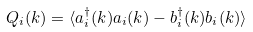<formula> <loc_0><loc_0><loc_500><loc_500>Q _ { i } ( k ) = \langle a _ { i } ^ { \dagger } ( k ) a _ { i } ( k ) - b _ { i } ^ { \dagger } ( k ) b _ { i } ( k ) \rangle</formula> 